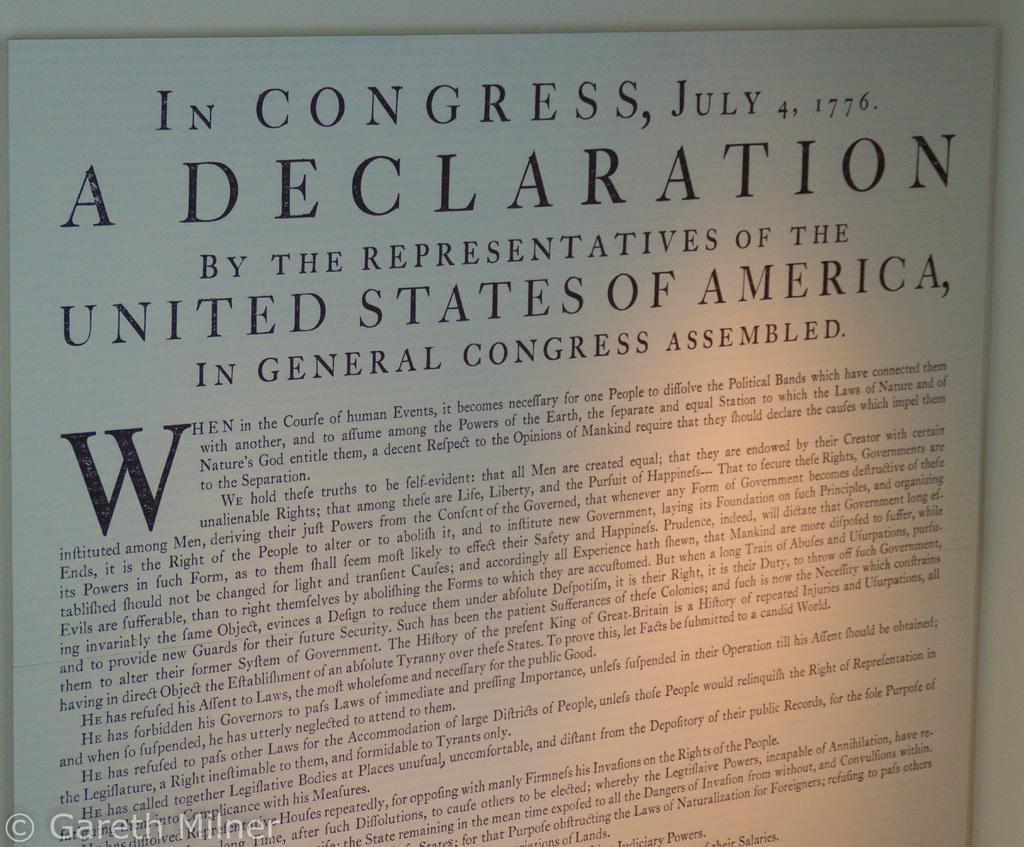<image>
Relay a brief, clear account of the picture shown. Paper hanging on a wall which starts off with "In Congress". 